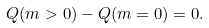Convert formula to latex. <formula><loc_0><loc_0><loc_500><loc_500>Q ( m > 0 ) - Q ( m = 0 ) = 0 .</formula> 